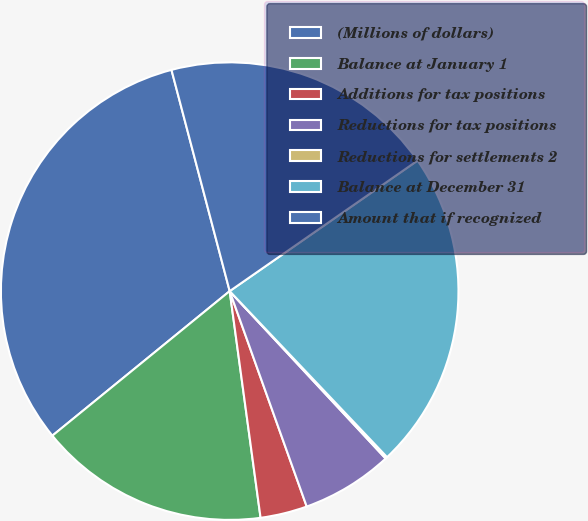<chart> <loc_0><loc_0><loc_500><loc_500><pie_chart><fcel>(Millions of dollars)<fcel>Balance at January 1<fcel>Additions for tax positions<fcel>Reductions for tax positions<fcel>Reductions for settlements 2<fcel>Balance at December 31<fcel>Amount that if recognized<nl><fcel>31.79%<fcel>16.27%<fcel>3.31%<fcel>6.47%<fcel>0.14%<fcel>22.59%<fcel>19.43%<nl></chart> 